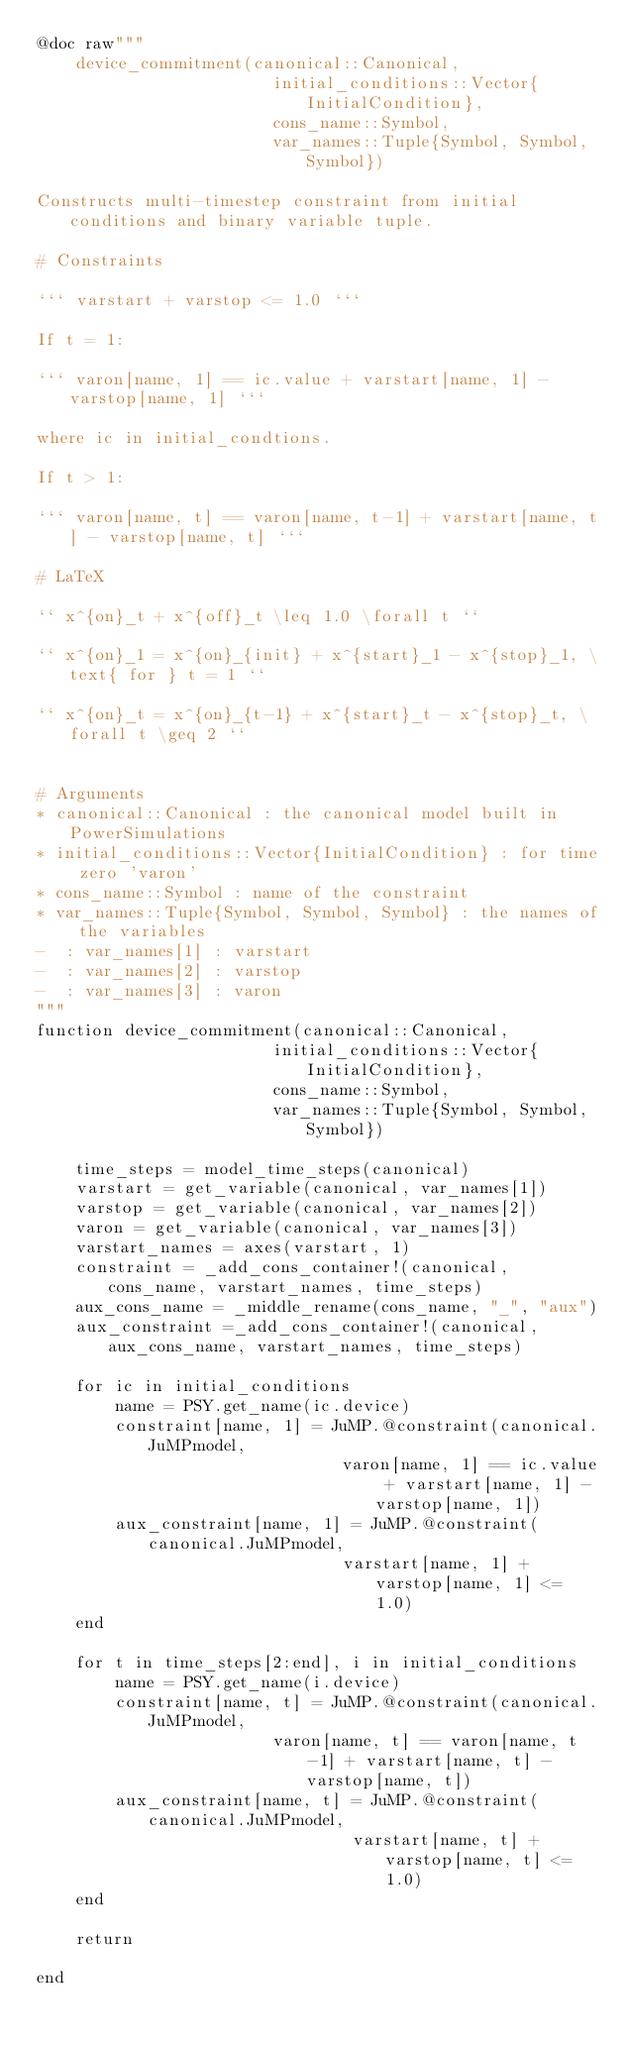Convert code to text. <code><loc_0><loc_0><loc_500><loc_500><_Julia_>@doc raw"""
    device_commitment(canonical::Canonical,
                        initial_conditions::Vector{InitialCondition},
                        cons_name::Symbol,
                        var_names::Tuple{Symbol, Symbol, Symbol})

Constructs multi-timestep constraint from initial conditions and binary variable tuple.

# Constraints

``` varstart + varstop <= 1.0 ```

If t = 1:

``` varon[name, 1] == ic.value + varstart[name, 1] - varstop[name, 1] ```

where ic in initial_condtions.

If t > 1:

``` varon[name, t] == varon[name, t-1] + varstart[name, t] - varstop[name, t] ```

# LaTeX

`` x^{on}_t + x^{off}_t \leq 1.0 \forall t ``

`` x^{on}_1 = x^{on}_{init} + x^{start}_1 - x^{stop}_1, \text{ for } t = 1 ``

`` x^{on}_t = x^{on}_{t-1} + x^{start}_t - x^{stop}_t, \forall t \geq 2 ``


# Arguments
* canonical::Canonical : the canonical model built in PowerSimulations
* initial_conditions::Vector{InitialCondition} : for time zero 'varon'
* cons_name::Symbol : name of the constraint
* var_names::Tuple{Symbol, Symbol, Symbol} : the names of the variables
-  : var_names[1] : varstart
-  : var_names[2] : varstop
-  : var_names[3] : varon
"""
function device_commitment(canonical::Canonical,
                        initial_conditions::Vector{InitialCondition},
                        cons_name::Symbol,
                        var_names::Tuple{Symbol, Symbol, Symbol})

    time_steps = model_time_steps(canonical)
    varstart = get_variable(canonical, var_names[1])
    varstop = get_variable(canonical, var_names[2])
    varon = get_variable(canonical, var_names[3])
    varstart_names = axes(varstart, 1)
    constraint = _add_cons_container!(canonical, cons_name, varstart_names, time_steps)
    aux_cons_name = _middle_rename(cons_name, "_", "aux")
    aux_constraint =_add_cons_container!(canonical, aux_cons_name, varstart_names, time_steps)

    for ic in initial_conditions
        name = PSY.get_name(ic.device)
        constraint[name, 1] = JuMP.@constraint(canonical.JuMPmodel,
                               varon[name, 1] == ic.value + varstart[name, 1] - varstop[name, 1])
        aux_constraint[name, 1] = JuMP.@constraint(canonical.JuMPmodel,
                               varstart[name, 1] + varstop[name, 1] <= 1.0)
    end

    for t in time_steps[2:end], i in initial_conditions
        name = PSY.get_name(i.device)
        constraint[name, t] = JuMP.@constraint(canonical.JuMPmodel,
                        varon[name, t] == varon[name, t-1] + varstart[name, t] - varstop[name, t])
        aux_constraint[name, t] = JuMP.@constraint(canonical.JuMPmodel,
                                varstart[name, t] + varstop[name, t] <= 1.0)
    end

    return

end
</code> 